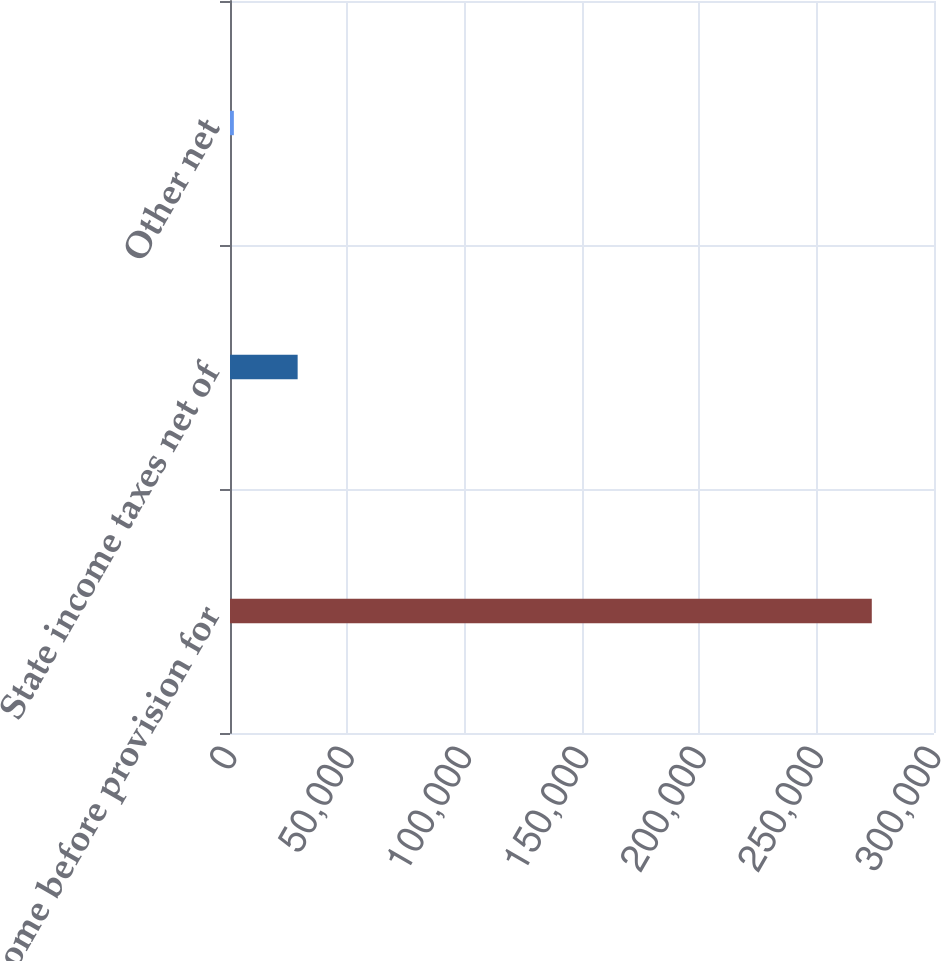<chart> <loc_0><loc_0><loc_500><loc_500><bar_chart><fcel>Income before provision for<fcel>State income taxes net of<fcel>Other net<nl><fcel>273488<fcel>28826.6<fcel>1642<nl></chart> 